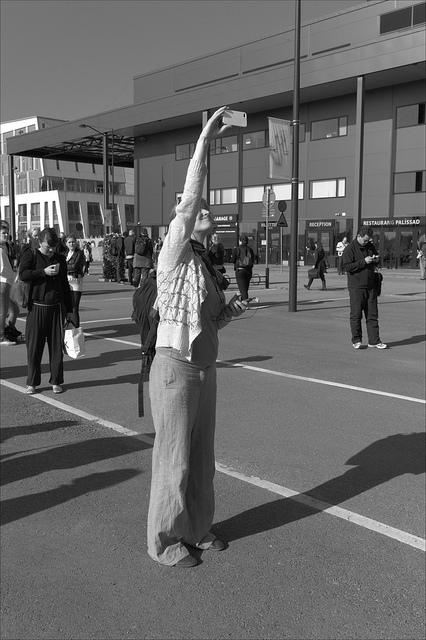Why is the woman holding her phone above her head? taking pictures 